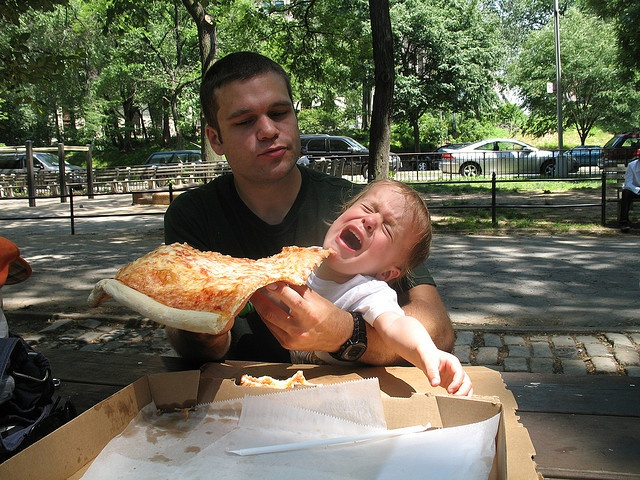Describe the objects in this image and their specific colors. I can see people in black, maroon, and brown tones, bench in black and gray tones, people in black, brown, white, and lightpink tones, pizza in black, tan, beige, and red tones, and car in black, white, gray, and darkgray tones in this image. 